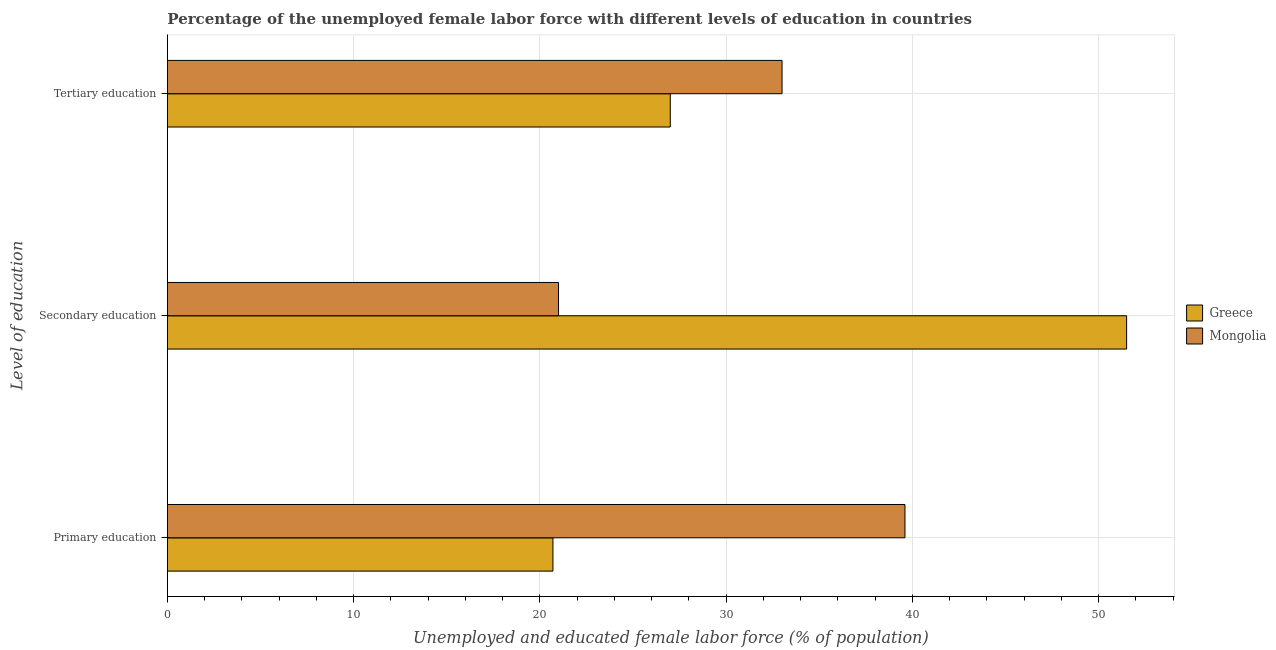How many groups of bars are there?
Your answer should be compact. 3. Are the number of bars per tick equal to the number of legend labels?
Your response must be concise. Yes. How many bars are there on the 2nd tick from the top?
Your response must be concise. 2. How many bars are there on the 3rd tick from the bottom?
Give a very brief answer. 2. What is the label of the 3rd group of bars from the top?
Provide a succinct answer. Primary education. Across all countries, what is the maximum percentage of female labor force who received secondary education?
Your answer should be very brief. 51.5. Across all countries, what is the minimum percentage of female labor force who received primary education?
Ensure brevity in your answer.  20.7. In which country was the percentage of female labor force who received tertiary education maximum?
Your answer should be compact. Mongolia. In which country was the percentage of female labor force who received secondary education minimum?
Your answer should be compact. Mongolia. What is the total percentage of female labor force who received tertiary education in the graph?
Keep it short and to the point. 60. What is the difference between the percentage of female labor force who received secondary education in Greece and that in Mongolia?
Keep it short and to the point. 30.5. What is the difference between the percentage of female labor force who received secondary education in Greece and the percentage of female labor force who received primary education in Mongolia?
Provide a short and direct response. 11.9. What is the average percentage of female labor force who received tertiary education per country?
Your answer should be very brief. 30. What is the difference between the percentage of female labor force who received primary education and percentage of female labor force who received secondary education in Greece?
Ensure brevity in your answer.  -30.8. What is the ratio of the percentage of female labor force who received tertiary education in Mongolia to that in Greece?
Your response must be concise. 1.22. Is the percentage of female labor force who received primary education in Greece less than that in Mongolia?
Your answer should be very brief. Yes. Is the difference between the percentage of female labor force who received secondary education in Mongolia and Greece greater than the difference between the percentage of female labor force who received tertiary education in Mongolia and Greece?
Your response must be concise. No. What is the difference between the highest and the second highest percentage of female labor force who received primary education?
Keep it short and to the point. 18.9. What is the difference between the highest and the lowest percentage of female labor force who received primary education?
Your answer should be compact. 18.9. In how many countries, is the percentage of female labor force who received tertiary education greater than the average percentage of female labor force who received tertiary education taken over all countries?
Ensure brevity in your answer.  1. Is the sum of the percentage of female labor force who received primary education in Greece and Mongolia greater than the maximum percentage of female labor force who received tertiary education across all countries?
Offer a terse response. Yes. What does the 1st bar from the top in Secondary education represents?
Offer a very short reply. Mongolia. What does the 2nd bar from the bottom in Tertiary education represents?
Provide a succinct answer. Mongolia. Is it the case that in every country, the sum of the percentage of female labor force who received primary education and percentage of female labor force who received secondary education is greater than the percentage of female labor force who received tertiary education?
Provide a short and direct response. Yes. How many bars are there?
Give a very brief answer. 6. How many countries are there in the graph?
Your answer should be very brief. 2. What is the difference between two consecutive major ticks on the X-axis?
Your response must be concise. 10. Are the values on the major ticks of X-axis written in scientific E-notation?
Give a very brief answer. No. Does the graph contain any zero values?
Provide a short and direct response. No. Does the graph contain grids?
Make the answer very short. Yes. How many legend labels are there?
Provide a short and direct response. 2. How are the legend labels stacked?
Keep it short and to the point. Vertical. What is the title of the graph?
Make the answer very short. Percentage of the unemployed female labor force with different levels of education in countries. What is the label or title of the X-axis?
Your answer should be compact. Unemployed and educated female labor force (% of population). What is the label or title of the Y-axis?
Your answer should be compact. Level of education. What is the Unemployed and educated female labor force (% of population) of Greece in Primary education?
Offer a very short reply. 20.7. What is the Unemployed and educated female labor force (% of population) in Mongolia in Primary education?
Keep it short and to the point. 39.6. What is the Unemployed and educated female labor force (% of population) in Greece in Secondary education?
Your answer should be compact. 51.5. What is the Unemployed and educated female labor force (% of population) in Mongolia in Secondary education?
Your answer should be compact. 21. Across all Level of education, what is the maximum Unemployed and educated female labor force (% of population) in Greece?
Your answer should be compact. 51.5. Across all Level of education, what is the maximum Unemployed and educated female labor force (% of population) of Mongolia?
Make the answer very short. 39.6. Across all Level of education, what is the minimum Unemployed and educated female labor force (% of population) in Greece?
Ensure brevity in your answer.  20.7. What is the total Unemployed and educated female labor force (% of population) of Greece in the graph?
Your answer should be compact. 99.2. What is the total Unemployed and educated female labor force (% of population) in Mongolia in the graph?
Give a very brief answer. 93.6. What is the difference between the Unemployed and educated female labor force (% of population) in Greece in Primary education and that in Secondary education?
Offer a very short reply. -30.8. What is the difference between the Unemployed and educated female labor force (% of population) in Mongolia in Primary education and that in Tertiary education?
Provide a short and direct response. 6.6. What is the difference between the Unemployed and educated female labor force (% of population) of Greece in Primary education and the Unemployed and educated female labor force (% of population) of Mongolia in Secondary education?
Keep it short and to the point. -0.3. What is the difference between the Unemployed and educated female labor force (% of population) of Greece in Primary education and the Unemployed and educated female labor force (% of population) of Mongolia in Tertiary education?
Offer a terse response. -12.3. What is the average Unemployed and educated female labor force (% of population) of Greece per Level of education?
Provide a short and direct response. 33.07. What is the average Unemployed and educated female labor force (% of population) of Mongolia per Level of education?
Give a very brief answer. 31.2. What is the difference between the Unemployed and educated female labor force (% of population) of Greece and Unemployed and educated female labor force (% of population) of Mongolia in Primary education?
Offer a very short reply. -18.9. What is the difference between the Unemployed and educated female labor force (% of population) in Greece and Unemployed and educated female labor force (% of population) in Mongolia in Secondary education?
Give a very brief answer. 30.5. What is the ratio of the Unemployed and educated female labor force (% of population) in Greece in Primary education to that in Secondary education?
Provide a short and direct response. 0.4. What is the ratio of the Unemployed and educated female labor force (% of population) in Mongolia in Primary education to that in Secondary education?
Offer a terse response. 1.89. What is the ratio of the Unemployed and educated female labor force (% of population) of Greece in Primary education to that in Tertiary education?
Ensure brevity in your answer.  0.77. What is the ratio of the Unemployed and educated female labor force (% of population) in Greece in Secondary education to that in Tertiary education?
Your answer should be very brief. 1.91. What is the ratio of the Unemployed and educated female labor force (% of population) in Mongolia in Secondary education to that in Tertiary education?
Make the answer very short. 0.64. What is the difference between the highest and the lowest Unemployed and educated female labor force (% of population) in Greece?
Ensure brevity in your answer.  30.8. What is the difference between the highest and the lowest Unemployed and educated female labor force (% of population) in Mongolia?
Provide a succinct answer. 18.6. 